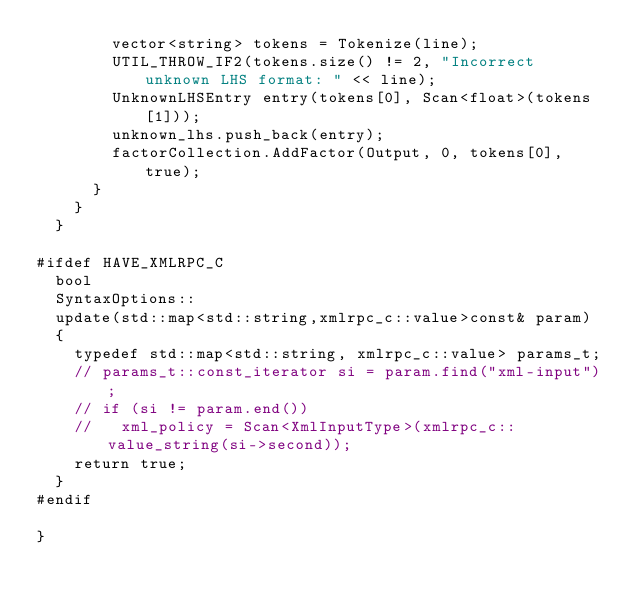Convert code to text. <code><loc_0><loc_0><loc_500><loc_500><_C++_>        vector<string> tokens = Tokenize(line);
        UTIL_THROW_IF2(tokens.size() != 2, "Incorrect unknown LHS format: " << line);
        UnknownLHSEntry entry(tokens[0], Scan<float>(tokens[1]));
        unknown_lhs.push_back(entry);
        factorCollection.AddFactor(Output, 0, tokens[0], true);
      }
    }
  }

#ifdef HAVE_XMLRPC_C
  bool 
  SyntaxOptions::
  update(std::map<std::string,xmlrpc_c::value>const& param)
  {
    typedef std::map<std::string, xmlrpc_c::value> params_t;
    // params_t::const_iterator si = param.find("xml-input");
    // if (si != param.end())
    //   xml_policy = Scan<XmlInputType>(xmlrpc_c::value_string(si->second));
    return true;
  }
#endif

}
</code> 